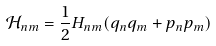Convert formula to latex. <formula><loc_0><loc_0><loc_500><loc_500>\mathcal { H } _ { n m } = \frac { 1 } { 2 } H _ { n m } ( q _ { n } q _ { m } + p _ { n } p _ { m } )</formula> 